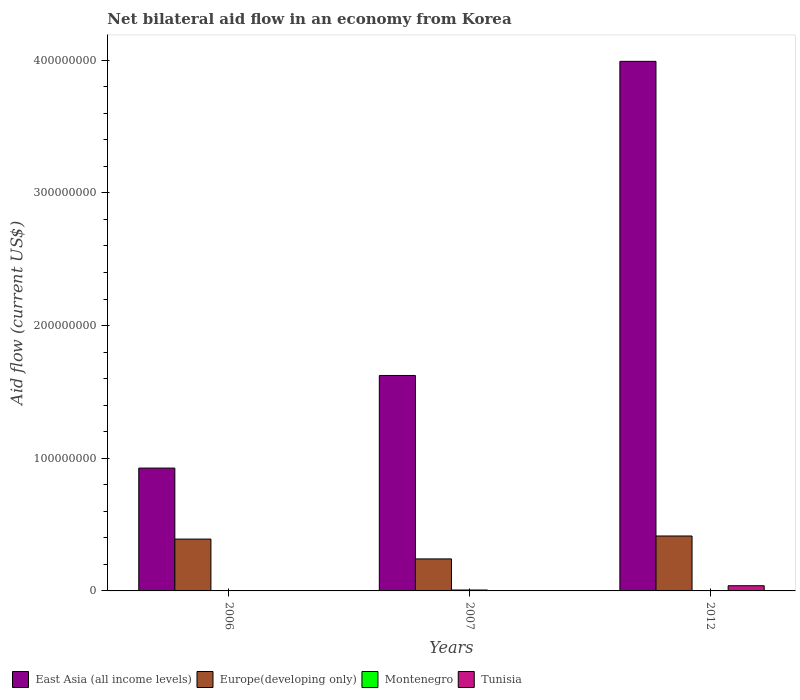How many bars are there on the 1st tick from the left?
Provide a succinct answer. 3. What is the net bilateral aid flow in Montenegro in 2007?
Provide a succinct answer. 6.90e+05. Across all years, what is the maximum net bilateral aid flow in Europe(developing only)?
Your answer should be compact. 4.14e+07. In which year was the net bilateral aid flow in Europe(developing only) maximum?
Ensure brevity in your answer.  2012. What is the total net bilateral aid flow in Montenegro in the graph?
Make the answer very short. 8.20e+05. What is the difference between the net bilateral aid flow in East Asia (all income levels) in 2007 and that in 2012?
Offer a very short reply. -2.37e+08. What is the difference between the net bilateral aid flow in Europe(developing only) in 2006 and the net bilateral aid flow in Montenegro in 2012?
Give a very brief answer. 3.90e+07. What is the average net bilateral aid flow in East Asia (all income levels) per year?
Give a very brief answer. 2.18e+08. In the year 2012, what is the difference between the net bilateral aid flow in East Asia (all income levels) and net bilateral aid flow in Tunisia?
Provide a succinct answer. 3.95e+08. What is the ratio of the net bilateral aid flow in East Asia (all income levels) in 2007 to that in 2012?
Your response must be concise. 0.41. Is the net bilateral aid flow in Europe(developing only) in 2007 less than that in 2012?
Give a very brief answer. Yes. What is the difference between the highest and the second highest net bilateral aid flow in Europe(developing only)?
Make the answer very short. 2.33e+06. What is the difference between the highest and the lowest net bilateral aid flow in Europe(developing only)?
Give a very brief answer. 1.73e+07. In how many years, is the net bilateral aid flow in Tunisia greater than the average net bilateral aid flow in Tunisia taken over all years?
Provide a short and direct response. 1. Is it the case that in every year, the sum of the net bilateral aid flow in Montenegro and net bilateral aid flow in East Asia (all income levels) is greater than the sum of net bilateral aid flow in Europe(developing only) and net bilateral aid flow in Tunisia?
Your response must be concise. Yes. Is it the case that in every year, the sum of the net bilateral aid flow in East Asia (all income levels) and net bilateral aid flow in Tunisia is greater than the net bilateral aid flow in Montenegro?
Ensure brevity in your answer.  Yes. What is the difference between two consecutive major ticks on the Y-axis?
Offer a terse response. 1.00e+08. Are the values on the major ticks of Y-axis written in scientific E-notation?
Give a very brief answer. No. Does the graph contain any zero values?
Your answer should be very brief. Yes. Where does the legend appear in the graph?
Ensure brevity in your answer.  Bottom left. How are the legend labels stacked?
Make the answer very short. Horizontal. What is the title of the graph?
Ensure brevity in your answer.  Net bilateral aid flow in an economy from Korea. Does "Tunisia" appear as one of the legend labels in the graph?
Offer a terse response. Yes. What is the label or title of the Y-axis?
Provide a short and direct response. Aid flow (current US$). What is the Aid flow (current US$) in East Asia (all income levels) in 2006?
Keep it short and to the point. 9.26e+07. What is the Aid flow (current US$) of Europe(developing only) in 2006?
Your answer should be compact. 3.91e+07. What is the Aid flow (current US$) in Montenegro in 2006?
Your answer should be very brief. 2.00e+04. What is the Aid flow (current US$) of Tunisia in 2006?
Offer a terse response. 0. What is the Aid flow (current US$) of East Asia (all income levels) in 2007?
Provide a short and direct response. 1.62e+08. What is the Aid flow (current US$) of Europe(developing only) in 2007?
Provide a succinct answer. 2.41e+07. What is the Aid flow (current US$) in Montenegro in 2007?
Your answer should be compact. 6.90e+05. What is the Aid flow (current US$) of East Asia (all income levels) in 2012?
Your answer should be very brief. 3.99e+08. What is the Aid flow (current US$) of Europe(developing only) in 2012?
Provide a short and direct response. 4.14e+07. What is the Aid flow (current US$) in Montenegro in 2012?
Keep it short and to the point. 1.10e+05. What is the Aid flow (current US$) of Tunisia in 2012?
Offer a terse response. 3.91e+06. Across all years, what is the maximum Aid flow (current US$) in East Asia (all income levels)?
Offer a terse response. 3.99e+08. Across all years, what is the maximum Aid flow (current US$) in Europe(developing only)?
Offer a very short reply. 4.14e+07. Across all years, what is the maximum Aid flow (current US$) in Montenegro?
Keep it short and to the point. 6.90e+05. Across all years, what is the maximum Aid flow (current US$) of Tunisia?
Offer a terse response. 3.91e+06. Across all years, what is the minimum Aid flow (current US$) of East Asia (all income levels)?
Provide a short and direct response. 9.26e+07. Across all years, what is the minimum Aid flow (current US$) in Europe(developing only)?
Keep it short and to the point. 2.41e+07. Across all years, what is the minimum Aid flow (current US$) of Montenegro?
Your response must be concise. 2.00e+04. What is the total Aid flow (current US$) in East Asia (all income levels) in the graph?
Ensure brevity in your answer.  6.54e+08. What is the total Aid flow (current US$) in Europe(developing only) in the graph?
Make the answer very short. 1.05e+08. What is the total Aid flow (current US$) in Montenegro in the graph?
Your answer should be very brief. 8.20e+05. What is the total Aid flow (current US$) in Tunisia in the graph?
Keep it short and to the point. 3.91e+06. What is the difference between the Aid flow (current US$) of East Asia (all income levels) in 2006 and that in 2007?
Provide a succinct answer. -6.98e+07. What is the difference between the Aid flow (current US$) in Europe(developing only) in 2006 and that in 2007?
Your answer should be very brief. 1.50e+07. What is the difference between the Aid flow (current US$) of Montenegro in 2006 and that in 2007?
Provide a succinct answer. -6.70e+05. What is the difference between the Aid flow (current US$) of East Asia (all income levels) in 2006 and that in 2012?
Make the answer very short. -3.07e+08. What is the difference between the Aid flow (current US$) in Europe(developing only) in 2006 and that in 2012?
Offer a very short reply. -2.33e+06. What is the difference between the Aid flow (current US$) of East Asia (all income levels) in 2007 and that in 2012?
Give a very brief answer. -2.37e+08. What is the difference between the Aid flow (current US$) of Europe(developing only) in 2007 and that in 2012?
Your response must be concise. -1.73e+07. What is the difference between the Aid flow (current US$) of Montenegro in 2007 and that in 2012?
Provide a succinct answer. 5.80e+05. What is the difference between the Aid flow (current US$) in East Asia (all income levels) in 2006 and the Aid flow (current US$) in Europe(developing only) in 2007?
Your answer should be very brief. 6.85e+07. What is the difference between the Aid flow (current US$) of East Asia (all income levels) in 2006 and the Aid flow (current US$) of Montenegro in 2007?
Offer a very short reply. 9.19e+07. What is the difference between the Aid flow (current US$) in Europe(developing only) in 2006 and the Aid flow (current US$) in Montenegro in 2007?
Give a very brief answer. 3.84e+07. What is the difference between the Aid flow (current US$) in East Asia (all income levels) in 2006 and the Aid flow (current US$) in Europe(developing only) in 2012?
Ensure brevity in your answer.  5.12e+07. What is the difference between the Aid flow (current US$) in East Asia (all income levels) in 2006 and the Aid flow (current US$) in Montenegro in 2012?
Your answer should be very brief. 9.25e+07. What is the difference between the Aid flow (current US$) in East Asia (all income levels) in 2006 and the Aid flow (current US$) in Tunisia in 2012?
Keep it short and to the point. 8.87e+07. What is the difference between the Aid flow (current US$) of Europe(developing only) in 2006 and the Aid flow (current US$) of Montenegro in 2012?
Provide a succinct answer. 3.90e+07. What is the difference between the Aid flow (current US$) in Europe(developing only) in 2006 and the Aid flow (current US$) in Tunisia in 2012?
Give a very brief answer. 3.52e+07. What is the difference between the Aid flow (current US$) in Montenegro in 2006 and the Aid flow (current US$) in Tunisia in 2012?
Give a very brief answer. -3.89e+06. What is the difference between the Aid flow (current US$) in East Asia (all income levels) in 2007 and the Aid flow (current US$) in Europe(developing only) in 2012?
Offer a very short reply. 1.21e+08. What is the difference between the Aid flow (current US$) in East Asia (all income levels) in 2007 and the Aid flow (current US$) in Montenegro in 2012?
Give a very brief answer. 1.62e+08. What is the difference between the Aid flow (current US$) in East Asia (all income levels) in 2007 and the Aid flow (current US$) in Tunisia in 2012?
Ensure brevity in your answer.  1.58e+08. What is the difference between the Aid flow (current US$) in Europe(developing only) in 2007 and the Aid flow (current US$) in Montenegro in 2012?
Provide a succinct answer. 2.40e+07. What is the difference between the Aid flow (current US$) in Europe(developing only) in 2007 and the Aid flow (current US$) in Tunisia in 2012?
Your answer should be very brief. 2.02e+07. What is the difference between the Aid flow (current US$) of Montenegro in 2007 and the Aid flow (current US$) of Tunisia in 2012?
Your answer should be compact. -3.22e+06. What is the average Aid flow (current US$) in East Asia (all income levels) per year?
Your response must be concise. 2.18e+08. What is the average Aid flow (current US$) of Europe(developing only) per year?
Keep it short and to the point. 3.49e+07. What is the average Aid flow (current US$) of Montenegro per year?
Offer a very short reply. 2.73e+05. What is the average Aid flow (current US$) in Tunisia per year?
Ensure brevity in your answer.  1.30e+06. In the year 2006, what is the difference between the Aid flow (current US$) of East Asia (all income levels) and Aid flow (current US$) of Europe(developing only)?
Your response must be concise. 5.35e+07. In the year 2006, what is the difference between the Aid flow (current US$) of East Asia (all income levels) and Aid flow (current US$) of Montenegro?
Your answer should be compact. 9.26e+07. In the year 2006, what is the difference between the Aid flow (current US$) of Europe(developing only) and Aid flow (current US$) of Montenegro?
Your answer should be very brief. 3.90e+07. In the year 2007, what is the difference between the Aid flow (current US$) in East Asia (all income levels) and Aid flow (current US$) in Europe(developing only)?
Provide a short and direct response. 1.38e+08. In the year 2007, what is the difference between the Aid flow (current US$) in East Asia (all income levels) and Aid flow (current US$) in Montenegro?
Provide a short and direct response. 1.62e+08. In the year 2007, what is the difference between the Aid flow (current US$) of Europe(developing only) and Aid flow (current US$) of Montenegro?
Keep it short and to the point. 2.34e+07. In the year 2012, what is the difference between the Aid flow (current US$) of East Asia (all income levels) and Aid flow (current US$) of Europe(developing only)?
Offer a very short reply. 3.58e+08. In the year 2012, what is the difference between the Aid flow (current US$) in East Asia (all income levels) and Aid flow (current US$) in Montenegro?
Offer a terse response. 3.99e+08. In the year 2012, what is the difference between the Aid flow (current US$) of East Asia (all income levels) and Aid flow (current US$) of Tunisia?
Your response must be concise. 3.95e+08. In the year 2012, what is the difference between the Aid flow (current US$) of Europe(developing only) and Aid flow (current US$) of Montenegro?
Your answer should be compact. 4.13e+07. In the year 2012, what is the difference between the Aid flow (current US$) in Europe(developing only) and Aid flow (current US$) in Tunisia?
Your answer should be very brief. 3.75e+07. In the year 2012, what is the difference between the Aid flow (current US$) in Montenegro and Aid flow (current US$) in Tunisia?
Offer a terse response. -3.80e+06. What is the ratio of the Aid flow (current US$) of East Asia (all income levels) in 2006 to that in 2007?
Provide a short and direct response. 0.57. What is the ratio of the Aid flow (current US$) in Europe(developing only) in 2006 to that in 2007?
Keep it short and to the point. 1.62. What is the ratio of the Aid flow (current US$) of Montenegro in 2006 to that in 2007?
Ensure brevity in your answer.  0.03. What is the ratio of the Aid flow (current US$) of East Asia (all income levels) in 2006 to that in 2012?
Give a very brief answer. 0.23. What is the ratio of the Aid flow (current US$) of Europe(developing only) in 2006 to that in 2012?
Give a very brief answer. 0.94. What is the ratio of the Aid flow (current US$) in Montenegro in 2006 to that in 2012?
Provide a short and direct response. 0.18. What is the ratio of the Aid flow (current US$) of East Asia (all income levels) in 2007 to that in 2012?
Make the answer very short. 0.41. What is the ratio of the Aid flow (current US$) of Europe(developing only) in 2007 to that in 2012?
Offer a terse response. 0.58. What is the ratio of the Aid flow (current US$) of Montenegro in 2007 to that in 2012?
Your response must be concise. 6.27. What is the difference between the highest and the second highest Aid flow (current US$) of East Asia (all income levels)?
Provide a short and direct response. 2.37e+08. What is the difference between the highest and the second highest Aid flow (current US$) of Europe(developing only)?
Ensure brevity in your answer.  2.33e+06. What is the difference between the highest and the second highest Aid flow (current US$) of Montenegro?
Provide a short and direct response. 5.80e+05. What is the difference between the highest and the lowest Aid flow (current US$) in East Asia (all income levels)?
Give a very brief answer. 3.07e+08. What is the difference between the highest and the lowest Aid flow (current US$) of Europe(developing only)?
Offer a very short reply. 1.73e+07. What is the difference between the highest and the lowest Aid flow (current US$) in Montenegro?
Offer a very short reply. 6.70e+05. What is the difference between the highest and the lowest Aid flow (current US$) of Tunisia?
Provide a short and direct response. 3.91e+06. 